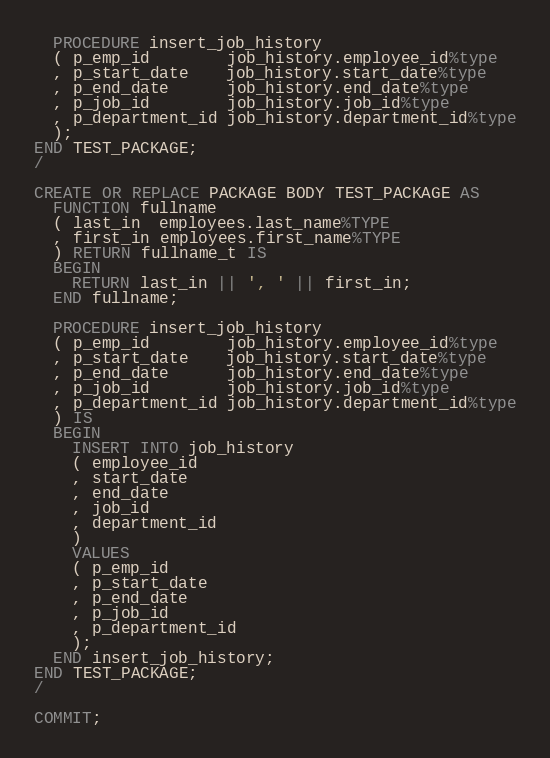Convert code to text. <code><loc_0><loc_0><loc_500><loc_500><_SQL_>  PROCEDURE insert_job_history
  ( p_emp_id        job_history.employee_id%type
  , p_start_date    job_history.start_date%type
  , p_end_date      job_history.end_date%type
  , p_job_id        job_history.job_id%type
  , p_department_id job_history.department_id%type
  );
END TEST_PACKAGE;
/

CREATE OR REPLACE PACKAGE BODY TEST_PACKAGE AS
  FUNCTION fullname
  ( last_in  employees.last_name%TYPE
  , first_in employees.first_name%TYPE
  ) RETURN fullname_t IS
  BEGIN
    RETURN last_in || ', ' || first_in;
  END fullname;

  PROCEDURE insert_job_history
  ( p_emp_id        job_history.employee_id%type
  , p_start_date    job_history.start_date%type
  , p_end_date      job_history.end_date%type
  , p_job_id        job_history.job_id%type
  , p_department_id job_history.department_id%type
  ) IS
  BEGIN
    INSERT INTO job_history
    ( employee_id
    , start_date
    , end_date
    , job_id
    , department_id
    )
    VALUES
    ( p_emp_id
    , p_start_date
    , p_end_date
    , p_job_id
    , p_department_id
    );
  END insert_job_history;
END TEST_PACKAGE;
/

COMMIT;
</code> 